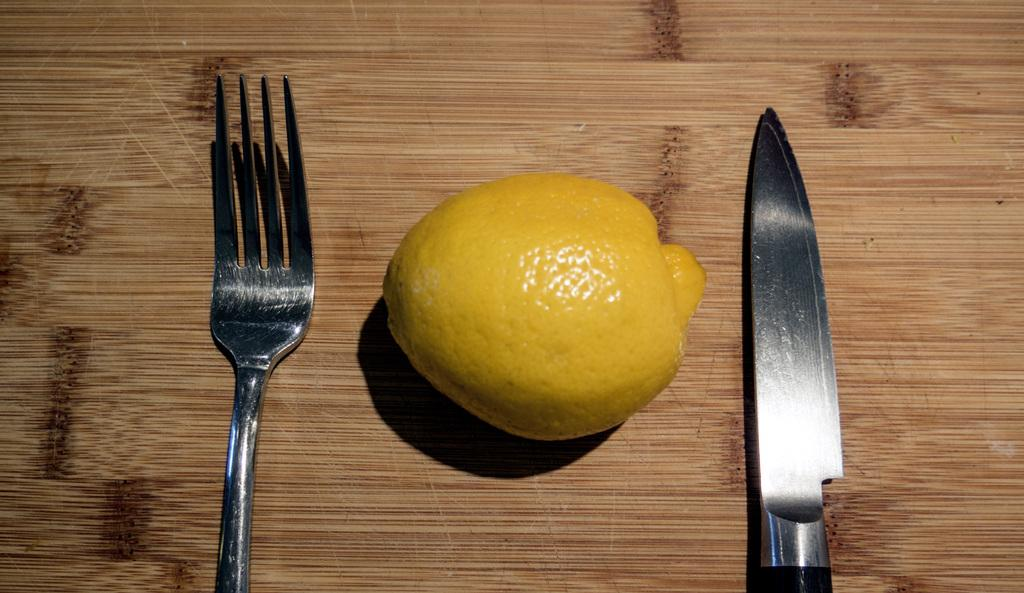What utensil can be seen in the image? There is a fork in the image. What fruit is present in the image? There is a lemon in the image. What other utensil is visible in the image? There is a knife in the image. Where are the fork, lemon, and knife located in the image? The fork, lemon, and knife are placed on a table. What type of shop can be seen in the background of the image? There is no shop present in the image; it only features a fork, lemon, and knife placed on a table. How does the porter assist in the image? There is no porter present in the image to assist with anything. 